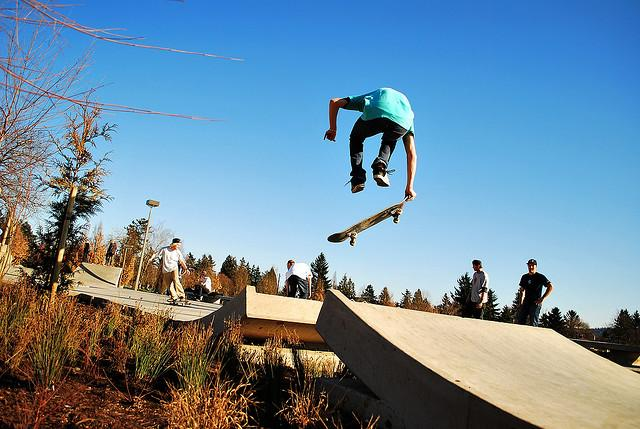Why is he grabbing the board?

Choices:
A) remove it
B) hold on
C) stop stealing
D) keep it keep it 